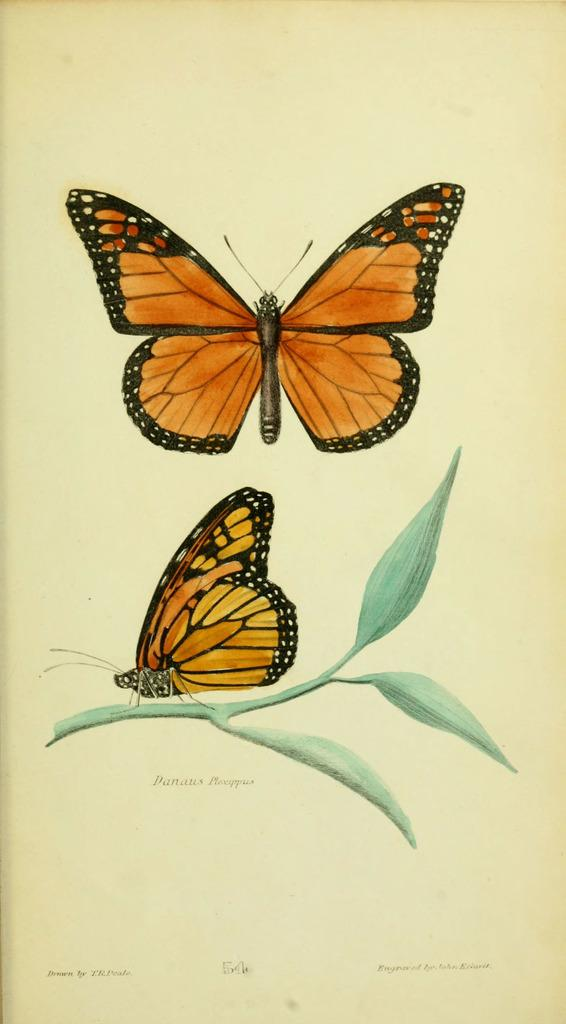What is the main subject of the poster in the image? The main subject of the poster in the image is two orange color butterflies. What is the position of one of the butterflies? One of the butterflies is standing on a stem. Are there any words or letters on the poster? Yes, there is text written around the image. What type of sound can be heard coming from the butterflies in the image? There is no sound coming from the butterflies in the image, as they are depicted in a static poster. What type of mindset does the achiever have in the image? There is no achiever mentioned or depicted in the image; it only features two orange color butterflies. 